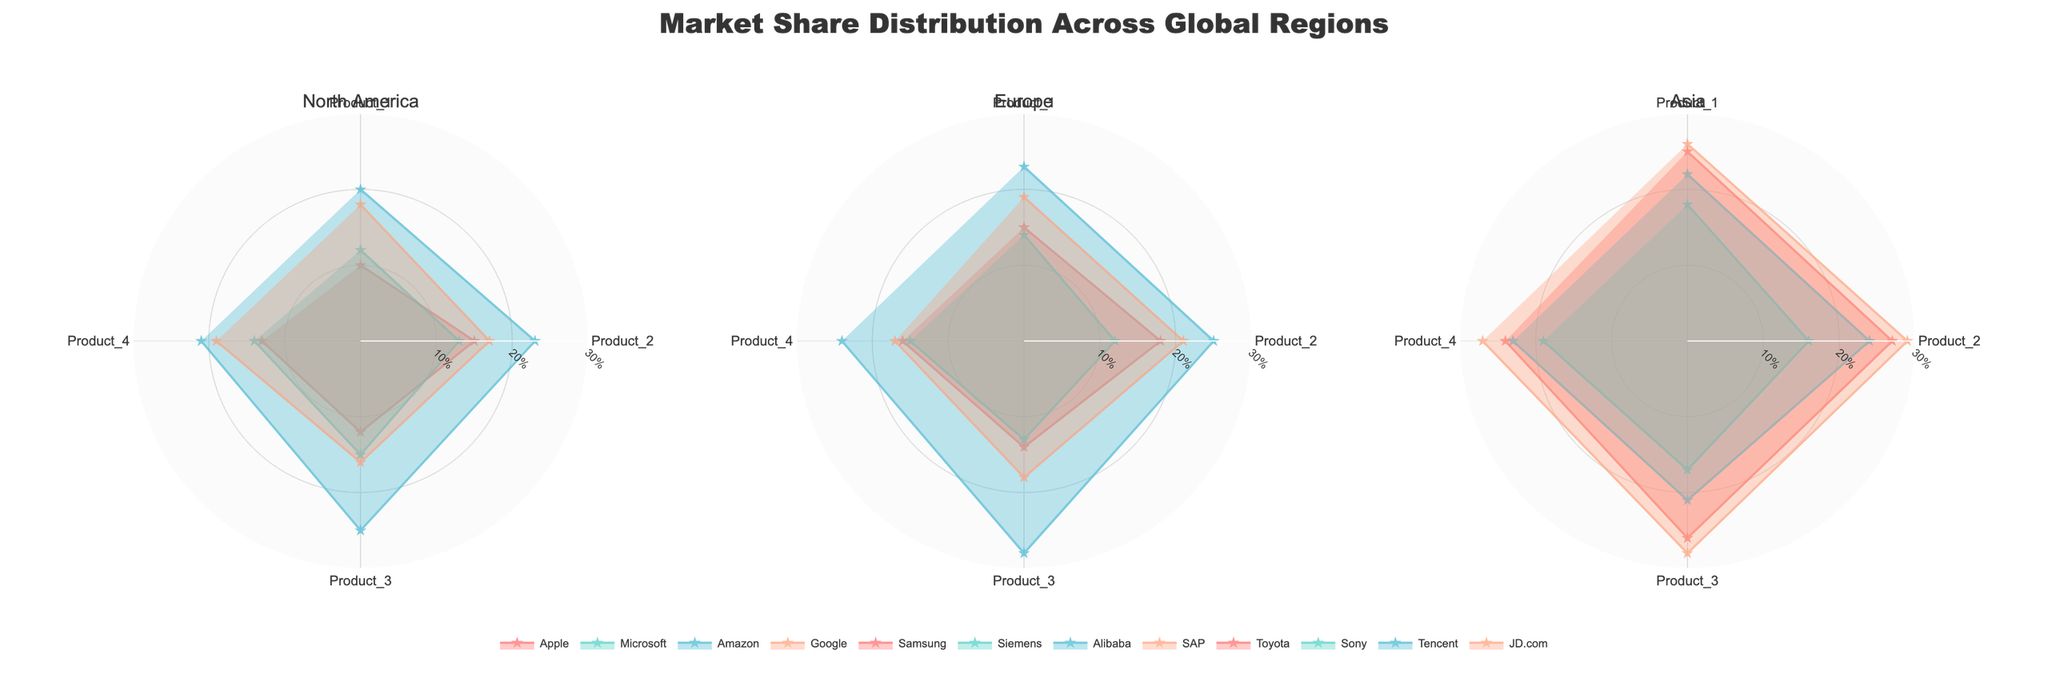Which region does Amazon dominate in market share across all products? By examining the North America subplot, Amazon consistently has higher radial axis values compared to other companies for each product.
Answer: North America Which company in Asia has the highest market share for Product_2? The radar chart for Asia shows JD.com with the highest radial value for Product_2 compared to other companies.
Answer: JD.com In Europe, which company has the lowest average market share across the four products? Calculate the average market share for each company in Europe. Siemens has the lowest average value when comparing the radial values for all products. Siemens: (0.14 + 0.12 + 0.13 + 0.15) / 4 = 0.135 average
Answer: Siemens What is the difference in market share between JD.com and Tencent for Product_4 in Asia? From the Asia radar chart, JD.com has a market share of 0.27, while Tencent has 0.23 for Product_4. Subtracting these gives: 0.27 - 0.23
Answer: 0.04 Which product has the most evenly distributed market share among all companies in North America? By visually inspecting the North America radar chart, Product_3 appears to have the least variance in market share among all companies, with values close to each other (0.12, 0.15, 0.25, 0.16).
Answer: Product_3 How does the market share of Toyota for Product_1 compare to all other companies in Asia? Toyota’s market share for Product_1 is 0.25, which is the highest value in the Asia subplot, indicating Toyota leads for Product_1 compared to others.
Answer: Highest What is the combined market share of E-commerce companies in Europe for Product_3? Sum the market shares of E-commerce companies (Alibaba) from the Europe subplot for Product_3: 0.28
Answer: 0.28 Which company has the most significant variation in market share across the four products within its region? Examine the radar charts for the variance in radial values. Alibaba in Europe shows high variation with significant differences across the four products (0.23, 0.25, 0.28, 0.24).
Answer: Alibaba Which company in North America has the highest market share for Product_4? From the North America radar chart, Amazon has the highest value for Product_4 at 0.21, compared to other companies.
Answer: Amazon 